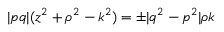Convert formula to latex. <formula><loc_0><loc_0><loc_500><loc_500>| p q | ( z ^ { 2 } + \rho ^ { 2 } - k ^ { 2 } ) = \pm | q ^ { 2 } - p ^ { 2 } | \rho k</formula> 